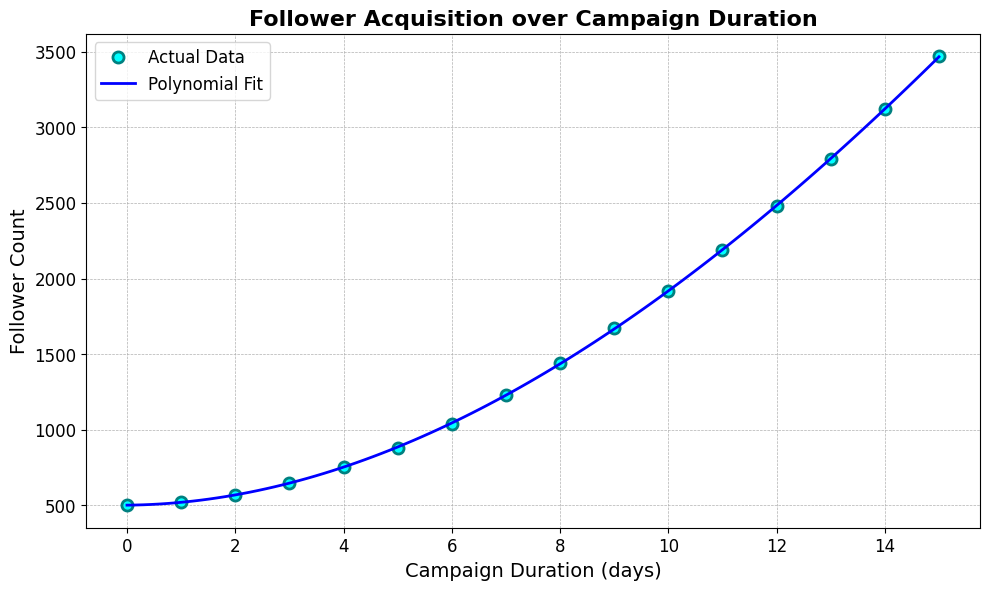What is the highest follower count achieved in the campaign? The highest follower count can be identified as the maximum value on the y-axis of the chart.
Answer: 3470 What is the polynomial order used for the fit line in the plot? The provided data and description mention that a 3rd order polynomial was used for the fit line.
Answer: 3rd order Which day shows the highest increase in follower count compared to the previous day? By observing the slope of the line between the points, the day with the steepest slope (highest increase) can be identified. Specifically, the steepest segment appears between day 5 and day 6.
Answer: Day 5 to Day 6 How is follower growth overall? Follower acquisition over the duration exhibits an increasing trend with growth accelerating over time, as indicated by the upward curve of the polynomial fit.
Answer: Increasing How many days does it take to reach a follower count of 2000? By looking at the plot, it is around day 11 that the follower count reaches 2000.
Answer: Approximately 11 days Which segment of the curve indicates the most rapid growth in followers? The most rapid growth is represented by the steepest portion of the curve, which occurs after day 8.
Answer: After day 8 What is the difference in follower count between day 3 and day 10? Use the y-values for day 3 (650) and day 10 (1920) and subtract to find the difference: 1920 - 650.
Answer: 1270 What is the color of the data points in the plot? The data points are colored teal with cyan fills according to the description provided.
Answer: Teal with cyan fills Does the growth of followers follow a linear trend? The growth follows a polynomial (non-linear) trend as indicated by the polynomial fit line.
Answer: No What is the polynomial function that fits the follower growth data? The polynomial function can be inferred from the fitted polynomial coefficients, but as not visually extractable from the plot, it is retained as more implicit knowledge from the plot generation context.
Answer: Polynomial (specific coefficients inferred from context) 